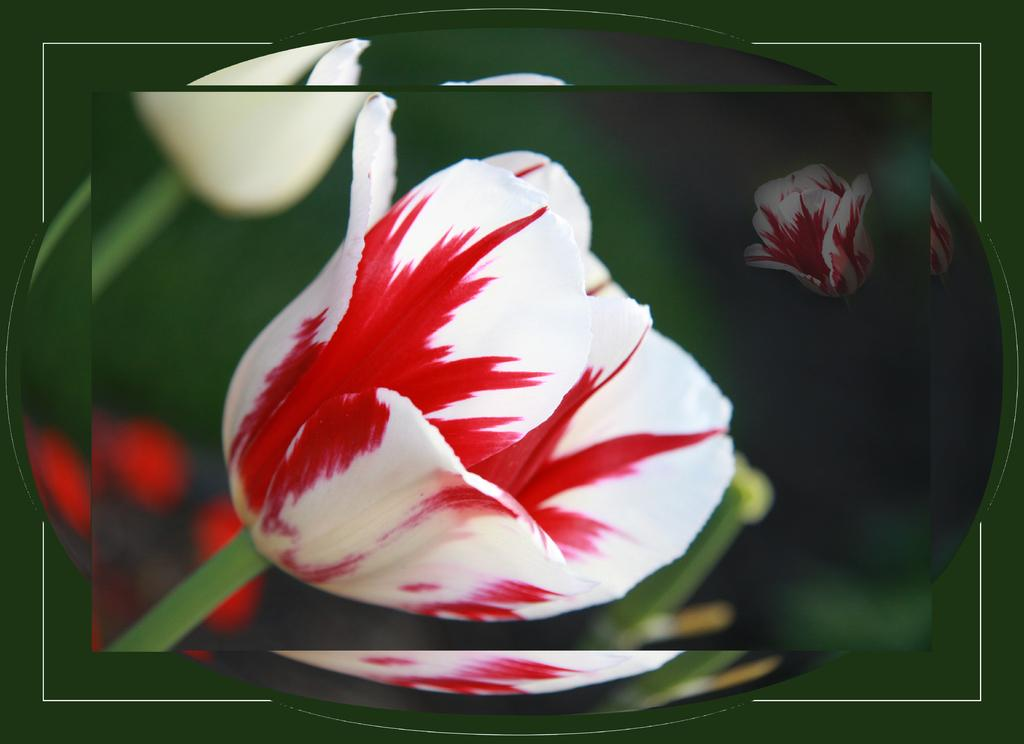What can be observed about the nature of the image? The image is edited. What is the main subject in the center of the image? There are pictures of flowers in the center of the image. Are there any other objects present in the center of the image? Yes, there are other objects in the center of the image. What color is the background of the image? The background of the image is green in color. What is the name of the person who died in the image? There is no person or death mentioned or depicted in the image. 